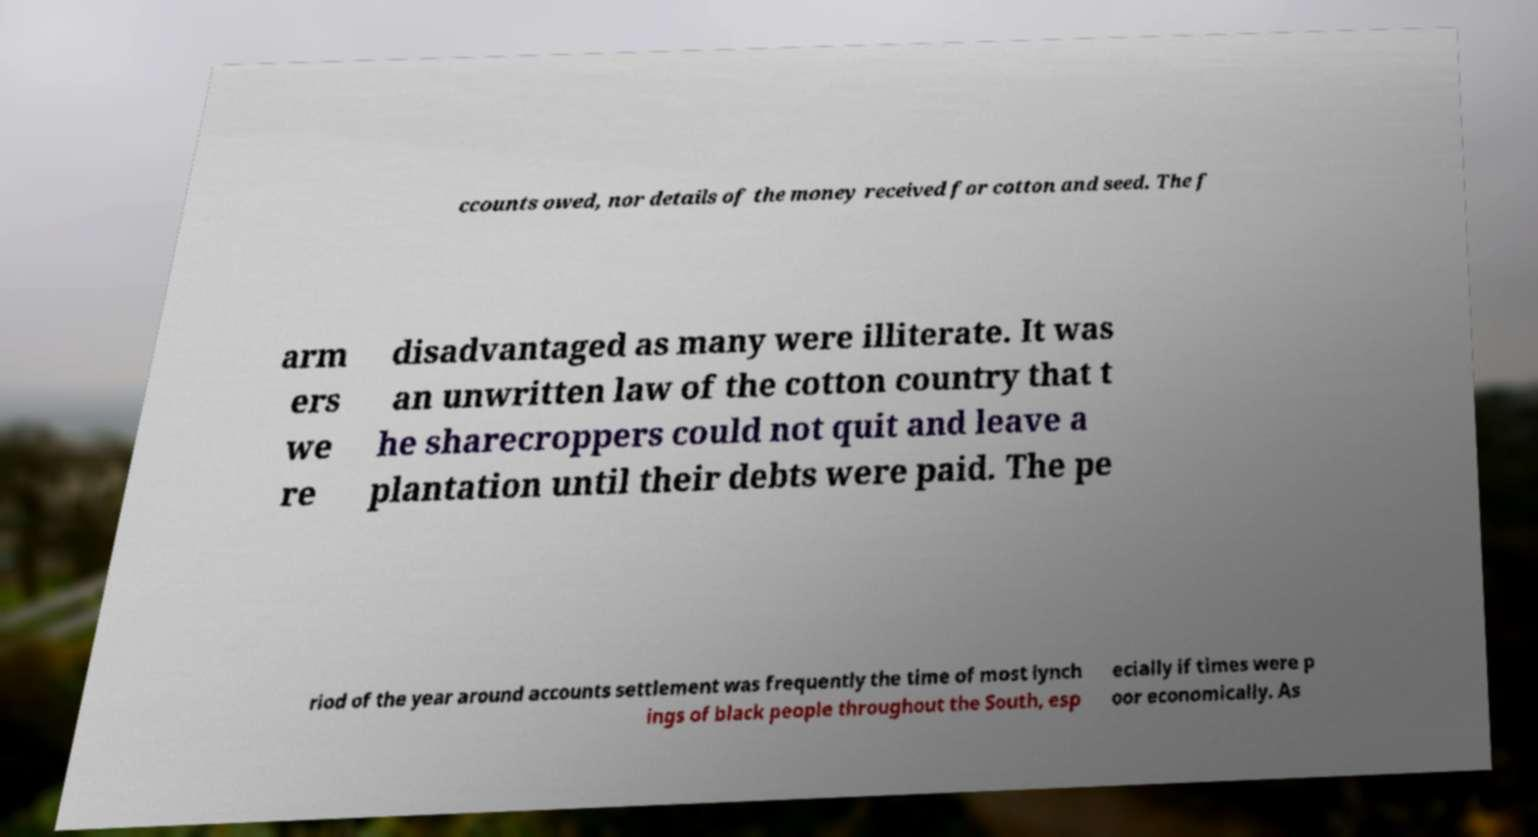Can you read and provide the text displayed in the image?This photo seems to have some interesting text. Can you extract and type it out for me? ccounts owed, nor details of the money received for cotton and seed. The f arm ers we re disadvantaged as many were illiterate. It was an unwritten law of the cotton country that t he sharecroppers could not quit and leave a plantation until their debts were paid. The pe riod of the year around accounts settlement was frequently the time of most lynch ings of black people throughout the South, esp ecially if times were p oor economically. As 